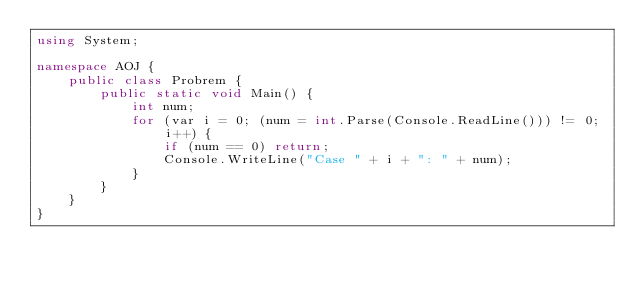Convert code to text. <code><loc_0><loc_0><loc_500><loc_500><_C#_>using System;

namespace AOJ {
    public class Probrem {
        public static void Main() {
            int num;
            for (var i = 0; (num = int.Parse(Console.ReadLine())) != 0; i++) {
                if (num == 0) return;
                Console.WriteLine("Case " + i + ": " + num);
            }
        }
    }
}
</code> 